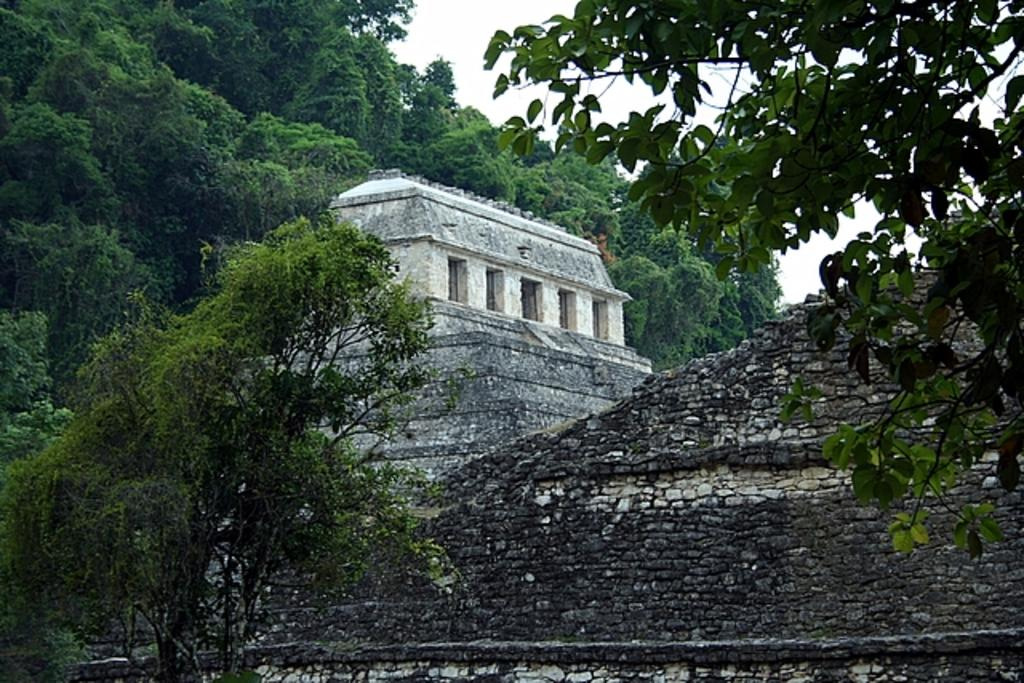What can be seen in the foreground of the image? There are trees and a wall in the foreground of the image. What is the main subject in the middle of the image? There appears to be a monument in the middle of the image. What is visible at the top of the image? The sky is visible at the top of the image. Can you tell me how many pets are sitting on the monument in the image? There are no pets present in the image, and therefore no such activity can be observed. What type of lip can be seen on the monument in the image? There is no lip present on the monument in the image. 